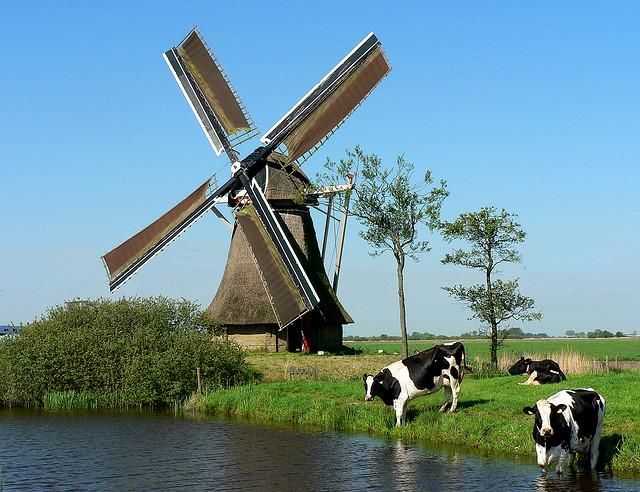What does the building do?

Choices:
A) walk
B) sing
C) spin
D) generate heat spin 